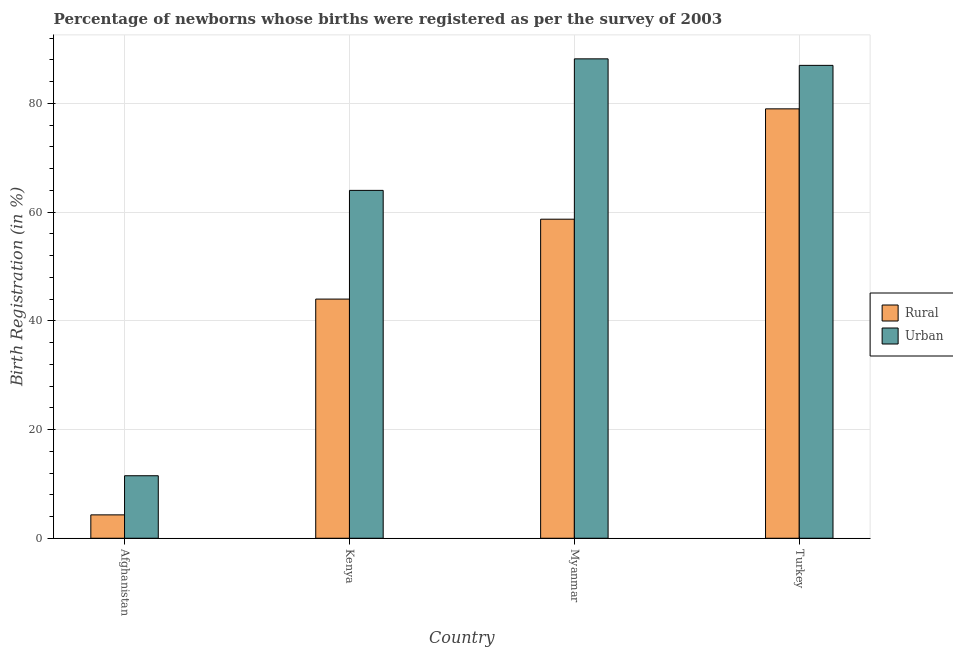How many groups of bars are there?
Provide a succinct answer. 4. Are the number of bars per tick equal to the number of legend labels?
Your response must be concise. Yes. How many bars are there on the 4th tick from the right?
Offer a terse response. 2. What is the label of the 1st group of bars from the left?
Ensure brevity in your answer.  Afghanistan. In how many cases, is the number of bars for a given country not equal to the number of legend labels?
Provide a succinct answer. 0. Across all countries, what is the maximum urban birth registration?
Provide a short and direct response. 88.2. Across all countries, what is the minimum rural birth registration?
Your answer should be compact. 4.3. In which country was the rural birth registration minimum?
Offer a very short reply. Afghanistan. What is the total urban birth registration in the graph?
Provide a succinct answer. 250.7. What is the difference between the rural birth registration in Myanmar and that in Turkey?
Ensure brevity in your answer.  -20.3. What is the difference between the urban birth registration in Afghanistan and the rural birth registration in Myanmar?
Keep it short and to the point. -47.2. What is the average rural birth registration per country?
Offer a terse response. 46.5. What is the ratio of the rural birth registration in Afghanistan to that in Kenya?
Offer a very short reply. 0.1. Is the difference between the urban birth registration in Myanmar and Turkey greater than the difference between the rural birth registration in Myanmar and Turkey?
Provide a short and direct response. Yes. What is the difference between the highest and the second highest urban birth registration?
Your answer should be compact. 1.2. What is the difference between the highest and the lowest rural birth registration?
Offer a terse response. 74.7. What does the 2nd bar from the left in Kenya represents?
Your answer should be very brief. Urban. What does the 2nd bar from the right in Afghanistan represents?
Ensure brevity in your answer.  Rural. How many bars are there?
Offer a very short reply. 8. Are all the bars in the graph horizontal?
Your answer should be compact. No. What is the difference between two consecutive major ticks on the Y-axis?
Keep it short and to the point. 20. Does the graph contain any zero values?
Provide a succinct answer. No. Where does the legend appear in the graph?
Ensure brevity in your answer.  Center right. How many legend labels are there?
Provide a succinct answer. 2. How are the legend labels stacked?
Provide a short and direct response. Vertical. What is the title of the graph?
Make the answer very short. Percentage of newborns whose births were registered as per the survey of 2003. What is the label or title of the Y-axis?
Provide a short and direct response. Birth Registration (in %). What is the Birth Registration (in %) of Rural in Afghanistan?
Provide a succinct answer. 4.3. What is the Birth Registration (in %) of Rural in Myanmar?
Keep it short and to the point. 58.7. What is the Birth Registration (in %) in Urban in Myanmar?
Give a very brief answer. 88.2. What is the Birth Registration (in %) in Rural in Turkey?
Offer a terse response. 79. What is the Birth Registration (in %) of Urban in Turkey?
Your answer should be very brief. 87. Across all countries, what is the maximum Birth Registration (in %) in Rural?
Give a very brief answer. 79. Across all countries, what is the maximum Birth Registration (in %) of Urban?
Your answer should be compact. 88.2. Across all countries, what is the minimum Birth Registration (in %) in Rural?
Give a very brief answer. 4.3. What is the total Birth Registration (in %) in Rural in the graph?
Provide a short and direct response. 186. What is the total Birth Registration (in %) in Urban in the graph?
Provide a short and direct response. 250.7. What is the difference between the Birth Registration (in %) in Rural in Afghanistan and that in Kenya?
Offer a terse response. -39.7. What is the difference between the Birth Registration (in %) of Urban in Afghanistan and that in Kenya?
Give a very brief answer. -52.5. What is the difference between the Birth Registration (in %) of Rural in Afghanistan and that in Myanmar?
Your answer should be compact. -54.4. What is the difference between the Birth Registration (in %) of Urban in Afghanistan and that in Myanmar?
Your answer should be compact. -76.7. What is the difference between the Birth Registration (in %) in Rural in Afghanistan and that in Turkey?
Give a very brief answer. -74.7. What is the difference between the Birth Registration (in %) of Urban in Afghanistan and that in Turkey?
Your answer should be very brief. -75.5. What is the difference between the Birth Registration (in %) in Rural in Kenya and that in Myanmar?
Give a very brief answer. -14.7. What is the difference between the Birth Registration (in %) of Urban in Kenya and that in Myanmar?
Ensure brevity in your answer.  -24.2. What is the difference between the Birth Registration (in %) in Rural in Kenya and that in Turkey?
Provide a succinct answer. -35. What is the difference between the Birth Registration (in %) of Rural in Myanmar and that in Turkey?
Provide a short and direct response. -20.3. What is the difference between the Birth Registration (in %) of Urban in Myanmar and that in Turkey?
Offer a very short reply. 1.2. What is the difference between the Birth Registration (in %) of Rural in Afghanistan and the Birth Registration (in %) of Urban in Kenya?
Offer a terse response. -59.7. What is the difference between the Birth Registration (in %) of Rural in Afghanistan and the Birth Registration (in %) of Urban in Myanmar?
Ensure brevity in your answer.  -83.9. What is the difference between the Birth Registration (in %) in Rural in Afghanistan and the Birth Registration (in %) in Urban in Turkey?
Offer a terse response. -82.7. What is the difference between the Birth Registration (in %) of Rural in Kenya and the Birth Registration (in %) of Urban in Myanmar?
Your answer should be very brief. -44.2. What is the difference between the Birth Registration (in %) of Rural in Kenya and the Birth Registration (in %) of Urban in Turkey?
Keep it short and to the point. -43. What is the difference between the Birth Registration (in %) in Rural in Myanmar and the Birth Registration (in %) in Urban in Turkey?
Keep it short and to the point. -28.3. What is the average Birth Registration (in %) of Rural per country?
Offer a terse response. 46.5. What is the average Birth Registration (in %) of Urban per country?
Your answer should be very brief. 62.67. What is the difference between the Birth Registration (in %) of Rural and Birth Registration (in %) of Urban in Kenya?
Make the answer very short. -20. What is the difference between the Birth Registration (in %) in Rural and Birth Registration (in %) in Urban in Myanmar?
Offer a very short reply. -29.5. What is the ratio of the Birth Registration (in %) in Rural in Afghanistan to that in Kenya?
Make the answer very short. 0.1. What is the ratio of the Birth Registration (in %) of Urban in Afghanistan to that in Kenya?
Offer a terse response. 0.18. What is the ratio of the Birth Registration (in %) of Rural in Afghanistan to that in Myanmar?
Your answer should be compact. 0.07. What is the ratio of the Birth Registration (in %) of Urban in Afghanistan to that in Myanmar?
Give a very brief answer. 0.13. What is the ratio of the Birth Registration (in %) in Rural in Afghanistan to that in Turkey?
Provide a short and direct response. 0.05. What is the ratio of the Birth Registration (in %) of Urban in Afghanistan to that in Turkey?
Your response must be concise. 0.13. What is the ratio of the Birth Registration (in %) in Rural in Kenya to that in Myanmar?
Give a very brief answer. 0.75. What is the ratio of the Birth Registration (in %) in Urban in Kenya to that in Myanmar?
Offer a terse response. 0.73. What is the ratio of the Birth Registration (in %) in Rural in Kenya to that in Turkey?
Your response must be concise. 0.56. What is the ratio of the Birth Registration (in %) of Urban in Kenya to that in Turkey?
Your answer should be compact. 0.74. What is the ratio of the Birth Registration (in %) of Rural in Myanmar to that in Turkey?
Offer a terse response. 0.74. What is the ratio of the Birth Registration (in %) in Urban in Myanmar to that in Turkey?
Keep it short and to the point. 1.01. What is the difference between the highest and the second highest Birth Registration (in %) in Rural?
Provide a succinct answer. 20.3. What is the difference between the highest and the second highest Birth Registration (in %) of Urban?
Give a very brief answer. 1.2. What is the difference between the highest and the lowest Birth Registration (in %) of Rural?
Keep it short and to the point. 74.7. What is the difference between the highest and the lowest Birth Registration (in %) of Urban?
Your answer should be compact. 76.7. 